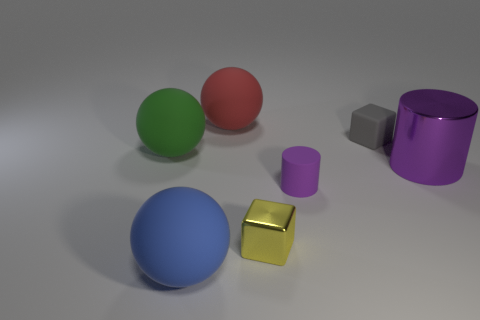Add 2 metal blocks. How many objects exist? 9 Subtract all balls. How many objects are left? 4 Add 1 yellow things. How many yellow things are left? 2 Add 6 brown rubber cubes. How many brown rubber cubes exist? 6 Subtract 0 cyan spheres. How many objects are left? 7 Subtract all large green things. Subtract all big purple shiny objects. How many objects are left? 5 